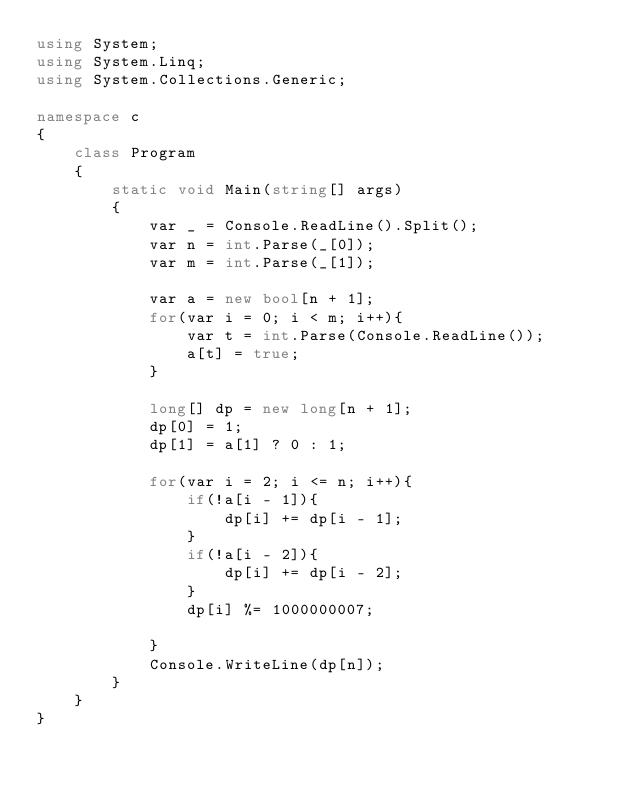Convert code to text. <code><loc_0><loc_0><loc_500><loc_500><_C#_>using System;
using System.Linq;
using System.Collections.Generic;

namespace c
{
    class Program
    {
        static void Main(string[] args)
        {
            var _ = Console.ReadLine().Split();
            var n = int.Parse(_[0]);
            var m = int.Parse(_[1]);

            var a = new bool[n + 1];
            for(var i = 0; i < m; i++){
                var t = int.Parse(Console.ReadLine());
                a[t] = true;
            }

            long[] dp = new long[n + 1];
            dp[0] = 1;
            dp[1] = a[1] ? 0 : 1;

            for(var i = 2; i <= n; i++){
                if(!a[i - 1]){
                    dp[i] += dp[i - 1]; 
                }
                if(!a[i - 2]){
                    dp[i] += dp[i - 2];
                }
                dp[i] %= 1000000007;

            }
            Console.WriteLine(dp[n]);
        }
    }
}
</code> 